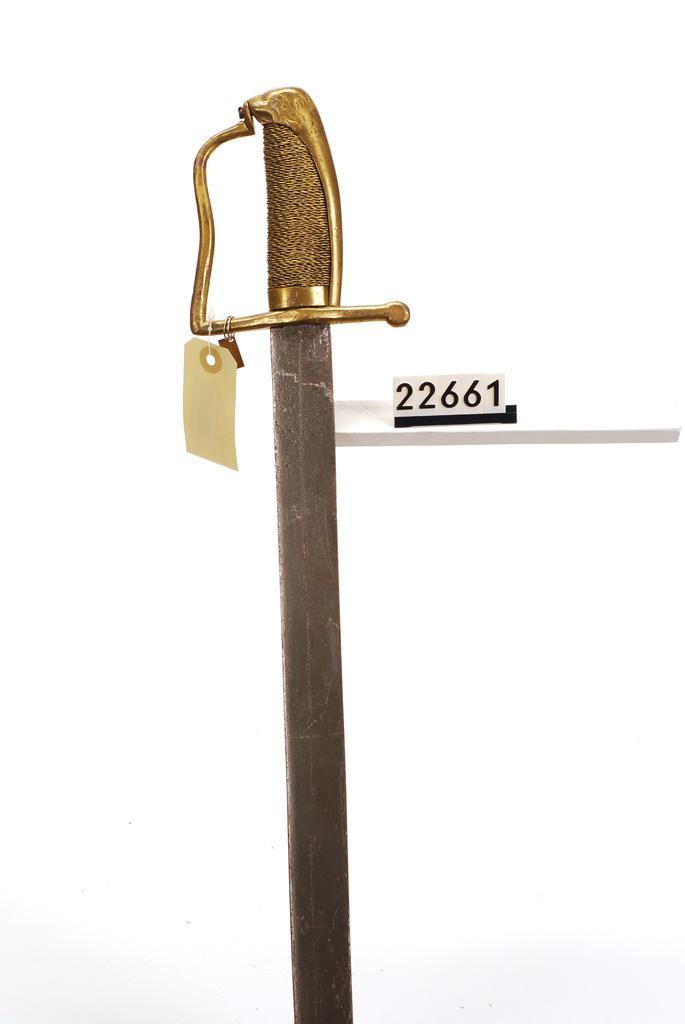Please provide a concise description of this image. In this picture we can see a sword and there is a tag. 